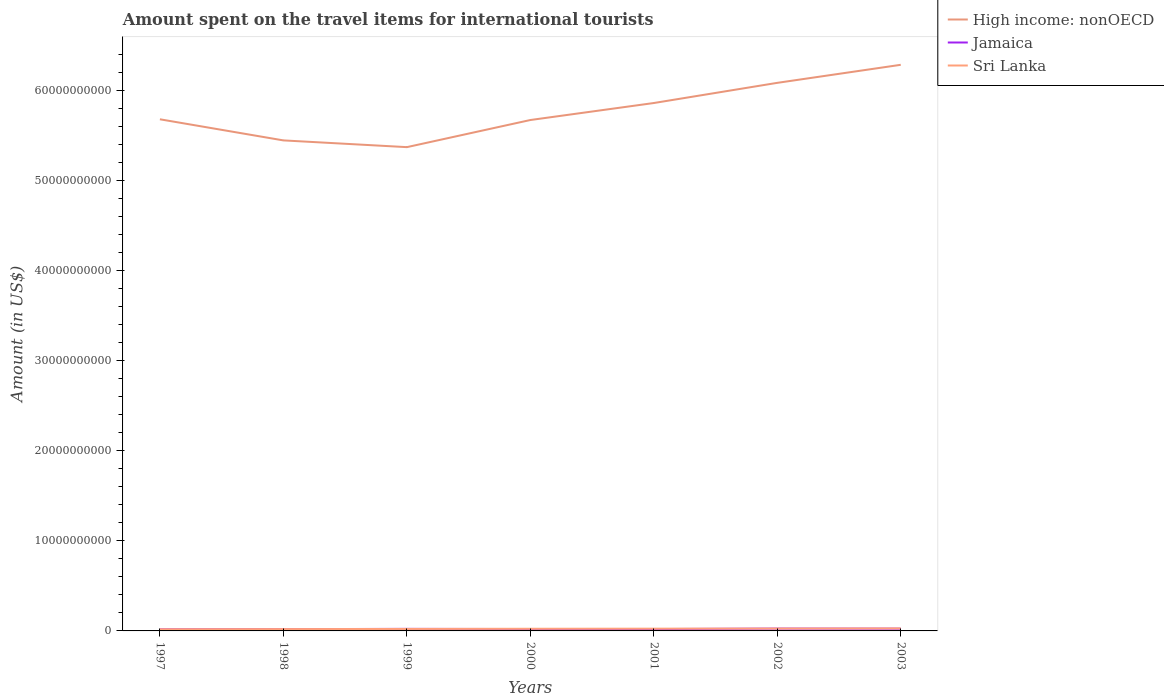Does the line corresponding to Sri Lanka intersect with the line corresponding to High income: nonOECD?
Provide a short and direct response. No. Is the number of lines equal to the number of legend labels?
Keep it short and to the point. Yes. Across all years, what is the maximum amount spent on the travel items for international tourists in High income: nonOECD?
Your answer should be very brief. 5.37e+1. What is the total amount spent on the travel items for international tourists in Jamaica in the graph?
Provide a succinct answer. -5.20e+07. What is the difference between the highest and the second highest amount spent on the travel items for international tourists in High income: nonOECD?
Provide a succinct answer. 9.14e+09. What is the difference between the highest and the lowest amount spent on the travel items for international tourists in Sri Lanka?
Provide a short and direct response. 4. Is the amount spent on the travel items for international tourists in Jamaica strictly greater than the amount spent on the travel items for international tourists in Sri Lanka over the years?
Ensure brevity in your answer.  No. What is the difference between two consecutive major ticks on the Y-axis?
Ensure brevity in your answer.  1.00e+1. Are the values on the major ticks of Y-axis written in scientific E-notation?
Keep it short and to the point. No. Does the graph contain any zero values?
Your response must be concise. No. Does the graph contain grids?
Make the answer very short. No. Where does the legend appear in the graph?
Make the answer very short. Top right. How many legend labels are there?
Keep it short and to the point. 3. How are the legend labels stacked?
Your answer should be compact. Vertical. What is the title of the graph?
Your answer should be very brief. Amount spent on the travel items for international tourists. What is the label or title of the X-axis?
Provide a succinct answer. Years. What is the label or title of the Y-axis?
Provide a succinct answer. Amount (in US$). What is the Amount (in US$) of High income: nonOECD in 1997?
Your answer should be very brief. 5.68e+1. What is the Amount (in US$) in Jamaica in 1997?
Make the answer very short. 1.81e+08. What is the Amount (in US$) of Sri Lanka in 1997?
Offer a terse response. 1.80e+08. What is the Amount (in US$) in High income: nonOECD in 1998?
Keep it short and to the point. 5.44e+1. What is the Amount (in US$) in Jamaica in 1998?
Provide a short and direct response. 1.98e+08. What is the Amount (in US$) of Sri Lanka in 1998?
Provide a short and direct response. 2.02e+08. What is the Amount (in US$) in High income: nonOECD in 1999?
Provide a succinct answer. 5.37e+1. What is the Amount (in US$) in Jamaica in 1999?
Offer a very short reply. 2.27e+08. What is the Amount (in US$) in Sri Lanka in 1999?
Make the answer very short. 2.18e+08. What is the Amount (in US$) in High income: nonOECD in 2000?
Your response must be concise. 5.67e+1. What is the Amount (in US$) in Jamaica in 2000?
Your response must be concise. 2.09e+08. What is the Amount (in US$) of Sri Lanka in 2000?
Your response must be concise. 2.40e+08. What is the Amount (in US$) of High income: nonOECD in 2001?
Offer a very short reply. 5.86e+1. What is the Amount (in US$) of Jamaica in 2001?
Your response must be concise. 2.06e+08. What is the Amount (in US$) of Sri Lanka in 2001?
Your answer should be very brief. 2.50e+08. What is the Amount (in US$) in High income: nonOECD in 2002?
Your response must be concise. 6.08e+1. What is the Amount (in US$) in Jamaica in 2002?
Your response must be concise. 2.58e+08. What is the Amount (in US$) of Sri Lanka in 2002?
Your answer should be very brief. 2.63e+08. What is the Amount (in US$) in High income: nonOECD in 2003?
Offer a terse response. 6.28e+1. What is the Amount (in US$) of Jamaica in 2003?
Your answer should be compact. 2.52e+08. What is the Amount (in US$) in Sri Lanka in 2003?
Your answer should be compact. 2.79e+08. Across all years, what is the maximum Amount (in US$) of High income: nonOECD?
Give a very brief answer. 6.28e+1. Across all years, what is the maximum Amount (in US$) of Jamaica?
Offer a terse response. 2.58e+08. Across all years, what is the maximum Amount (in US$) of Sri Lanka?
Provide a succinct answer. 2.79e+08. Across all years, what is the minimum Amount (in US$) in High income: nonOECD?
Keep it short and to the point. 5.37e+1. Across all years, what is the minimum Amount (in US$) in Jamaica?
Make the answer very short. 1.81e+08. Across all years, what is the minimum Amount (in US$) in Sri Lanka?
Make the answer very short. 1.80e+08. What is the total Amount (in US$) of High income: nonOECD in the graph?
Make the answer very short. 4.04e+11. What is the total Amount (in US$) of Jamaica in the graph?
Keep it short and to the point. 1.53e+09. What is the total Amount (in US$) of Sri Lanka in the graph?
Offer a very short reply. 1.63e+09. What is the difference between the Amount (in US$) in High income: nonOECD in 1997 and that in 1998?
Provide a succinct answer. 2.34e+09. What is the difference between the Amount (in US$) in Jamaica in 1997 and that in 1998?
Offer a terse response. -1.70e+07. What is the difference between the Amount (in US$) in Sri Lanka in 1997 and that in 1998?
Your answer should be compact. -2.20e+07. What is the difference between the Amount (in US$) of High income: nonOECD in 1997 and that in 1999?
Provide a succinct answer. 3.09e+09. What is the difference between the Amount (in US$) in Jamaica in 1997 and that in 1999?
Give a very brief answer. -4.60e+07. What is the difference between the Amount (in US$) in Sri Lanka in 1997 and that in 1999?
Make the answer very short. -3.80e+07. What is the difference between the Amount (in US$) in High income: nonOECD in 1997 and that in 2000?
Your response must be concise. 8.31e+07. What is the difference between the Amount (in US$) in Jamaica in 1997 and that in 2000?
Make the answer very short. -2.80e+07. What is the difference between the Amount (in US$) of Sri Lanka in 1997 and that in 2000?
Provide a short and direct response. -6.00e+07. What is the difference between the Amount (in US$) of High income: nonOECD in 1997 and that in 2001?
Ensure brevity in your answer.  -1.80e+09. What is the difference between the Amount (in US$) in Jamaica in 1997 and that in 2001?
Give a very brief answer. -2.50e+07. What is the difference between the Amount (in US$) in Sri Lanka in 1997 and that in 2001?
Your response must be concise. -7.00e+07. What is the difference between the Amount (in US$) of High income: nonOECD in 1997 and that in 2002?
Your answer should be very brief. -4.04e+09. What is the difference between the Amount (in US$) of Jamaica in 1997 and that in 2002?
Your answer should be compact. -7.70e+07. What is the difference between the Amount (in US$) in Sri Lanka in 1997 and that in 2002?
Provide a succinct answer. -8.30e+07. What is the difference between the Amount (in US$) of High income: nonOECD in 1997 and that in 2003?
Provide a succinct answer. -6.05e+09. What is the difference between the Amount (in US$) of Jamaica in 1997 and that in 2003?
Keep it short and to the point. -7.10e+07. What is the difference between the Amount (in US$) of Sri Lanka in 1997 and that in 2003?
Your answer should be very brief. -9.90e+07. What is the difference between the Amount (in US$) in High income: nonOECD in 1998 and that in 1999?
Your answer should be compact. 7.48e+08. What is the difference between the Amount (in US$) in Jamaica in 1998 and that in 1999?
Your response must be concise. -2.90e+07. What is the difference between the Amount (in US$) in Sri Lanka in 1998 and that in 1999?
Your answer should be compact. -1.60e+07. What is the difference between the Amount (in US$) in High income: nonOECD in 1998 and that in 2000?
Offer a terse response. -2.26e+09. What is the difference between the Amount (in US$) in Jamaica in 1998 and that in 2000?
Keep it short and to the point. -1.10e+07. What is the difference between the Amount (in US$) of Sri Lanka in 1998 and that in 2000?
Provide a succinct answer. -3.80e+07. What is the difference between the Amount (in US$) in High income: nonOECD in 1998 and that in 2001?
Offer a terse response. -4.15e+09. What is the difference between the Amount (in US$) of Jamaica in 1998 and that in 2001?
Your response must be concise. -8.00e+06. What is the difference between the Amount (in US$) in Sri Lanka in 1998 and that in 2001?
Offer a terse response. -4.80e+07. What is the difference between the Amount (in US$) in High income: nonOECD in 1998 and that in 2002?
Provide a short and direct response. -6.39e+09. What is the difference between the Amount (in US$) in Jamaica in 1998 and that in 2002?
Make the answer very short. -6.00e+07. What is the difference between the Amount (in US$) of Sri Lanka in 1998 and that in 2002?
Provide a short and direct response. -6.10e+07. What is the difference between the Amount (in US$) of High income: nonOECD in 1998 and that in 2003?
Offer a very short reply. -8.39e+09. What is the difference between the Amount (in US$) in Jamaica in 1998 and that in 2003?
Keep it short and to the point. -5.40e+07. What is the difference between the Amount (in US$) in Sri Lanka in 1998 and that in 2003?
Provide a short and direct response. -7.70e+07. What is the difference between the Amount (in US$) of High income: nonOECD in 1999 and that in 2000?
Your answer should be compact. -3.01e+09. What is the difference between the Amount (in US$) in Jamaica in 1999 and that in 2000?
Your answer should be compact. 1.80e+07. What is the difference between the Amount (in US$) in Sri Lanka in 1999 and that in 2000?
Ensure brevity in your answer.  -2.20e+07. What is the difference between the Amount (in US$) of High income: nonOECD in 1999 and that in 2001?
Offer a terse response. -4.90e+09. What is the difference between the Amount (in US$) of Jamaica in 1999 and that in 2001?
Provide a short and direct response. 2.10e+07. What is the difference between the Amount (in US$) in Sri Lanka in 1999 and that in 2001?
Ensure brevity in your answer.  -3.20e+07. What is the difference between the Amount (in US$) of High income: nonOECD in 1999 and that in 2002?
Give a very brief answer. -7.14e+09. What is the difference between the Amount (in US$) of Jamaica in 1999 and that in 2002?
Make the answer very short. -3.10e+07. What is the difference between the Amount (in US$) in Sri Lanka in 1999 and that in 2002?
Make the answer very short. -4.50e+07. What is the difference between the Amount (in US$) of High income: nonOECD in 1999 and that in 2003?
Your response must be concise. -9.14e+09. What is the difference between the Amount (in US$) in Jamaica in 1999 and that in 2003?
Make the answer very short. -2.50e+07. What is the difference between the Amount (in US$) of Sri Lanka in 1999 and that in 2003?
Ensure brevity in your answer.  -6.10e+07. What is the difference between the Amount (in US$) in High income: nonOECD in 2000 and that in 2001?
Make the answer very short. -1.89e+09. What is the difference between the Amount (in US$) in Jamaica in 2000 and that in 2001?
Provide a succinct answer. 3.00e+06. What is the difference between the Amount (in US$) in Sri Lanka in 2000 and that in 2001?
Give a very brief answer. -1.00e+07. What is the difference between the Amount (in US$) in High income: nonOECD in 2000 and that in 2002?
Your answer should be very brief. -4.13e+09. What is the difference between the Amount (in US$) in Jamaica in 2000 and that in 2002?
Offer a terse response. -4.90e+07. What is the difference between the Amount (in US$) of Sri Lanka in 2000 and that in 2002?
Give a very brief answer. -2.30e+07. What is the difference between the Amount (in US$) of High income: nonOECD in 2000 and that in 2003?
Provide a short and direct response. -6.13e+09. What is the difference between the Amount (in US$) of Jamaica in 2000 and that in 2003?
Keep it short and to the point. -4.30e+07. What is the difference between the Amount (in US$) of Sri Lanka in 2000 and that in 2003?
Offer a terse response. -3.90e+07. What is the difference between the Amount (in US$) in High income: nonOECD in 2001 and that in 2002?
Offer a very short reply. -2.24e+09. What is the difference between the Amount (in US$) in Jamaica in 2001 and that in 2002?
Keep it short and to the point. -5.20e+07. What is the difference between the Amount (in US$) in Sri Lanka in 2001 and that in 2002?
Make the answer very short. -1.30e+07. What is the difference between the Amount (in US$) of High income: nonOECD in 2001 and that in 2003?
Offer a terse response. -4.24e+09. What is the difference between the Amount (in US$) of Jamaica in 2001 and that in 2003?
Your answer should be very brief. -4.60e+07. What is the difference between the Amount (in US$) of Sri Lanka in 2001 and that in 2003?
Provide a short and direct response. -2.90e+07. What is the difference between the Amount (in US$) of High income: nonOECD in 2002 and that in 2003?
Your response must be concise. -2.00e+09. What is the difference between the Amount (in US$) in Sri Lanka in 2002 and that in 2003?
Offer a terse response. -1.60e+07. What is the difference between the Amount (in US$) in High income: nonOECD in 1997 and the Amount (in US$) in Jamaica in 1998?
Offer a very short reply. 5.66e+1. What is the difference between the Amount (in US$) of High income: nonOECD in 1997 and the Amount (in US$) of Sri Lanka in 1998?
Give a very brief answer. 5.66e+1. What is the difference between the Amount (in US$) in Jamaica in 1997 and the Amount (in US$) in Sri Lanka in 1998?
Ensure brevity in your answer.  -2.10e+07. What is the difference between the Amount (in US$) in High income: nonOECD in 1997 and the Amount (in US$) in Jamaica in 1999?
Your answer should be compact. 5.66e+1. What is the difference between the Amount (in US$) of High income: nonOECD in 1997 and the Amount (in US$) of Sri Lanka in 1999?
Provide a succinct answer. 5.66e+1. What is the difference between the Amount (in US$) in Jamaica in 1997 and the Amount (in US$) in Sri Lanka in 1999?
Ensure brevity in your answer.  -3.70e+07. What is the difference between the Amount (in US$) of High income: nonOECD in 1997 and the Amount (in US$) of Jamaica in 2000?
Make the answer very short. 5.66e+1. What is the difference between the Amount (in US$) in High income: nonOECD in 1997 and the Amount (in US$) in Sri Lanka in 2000?
Give a very brief answer. 5.65e+1. What is the difference between the Amount (in US$) of Jamaica in 1997 and the Amount (in US$) of Sri Lanka in 2000?
Provide a short and direct response. -5.90e+07. What is the difference between the Amount (in US$) in High income: nonOECD in 1997 and the Amount (in US$) in Jamaica in 2001?
Keep it short and to the point. 5.66e+1. What is the difference between the Amount (in US$) of High income: nonOECD in 1997 and the Amount (in US$) of Sri Lanka in 2001?
Your answer should be compact. 5.65e+1. What is the difference between the Amount (in US$) of Jamaica in 1997 and the Amount (in US$) of Sri Lanka in 2001?
Your answer should be very brief. -6.90e+07. What is the difference between the Amount (in US$) of High income: nonOECD in 1997 and the Amount (in US$) of Jamaica in 2002?
Provide a short and direct response. 5.65e+1. What is the difference between the Amount (in US$) of High income: nonOECD in 1997 and the Amount (in US$) of Sri Lanka in 2002?
Your response must be concise. 5.65e+1. What is the difference between the Amount (in US$) of Jamaica in 1997 and the Amount (in US$) of Sri Lanka in 2002?
Provide a short and direct response. -8.20e+07. What is the difference between the Amount (in US$) in High income: nonOECD in 1997 and the Amount (in US$) in Jamaica in 2003?
Give a very brief answer. 5.65e+1. What is the difference between the Amount (in US$) in High income: nonOECD in 1997 and the Amount (in US$) in Sri Lanka in 2003?
Keep it short and to the point. 5.65e+1. What is the difference between the Amount (in US$) of Jamaica in 1997 and the Amount (in US$) of Sri Lanka in 2003?
Give a very brief answer. -9.80e+07. What is the difference between the Amount (in US$) in High income: nonOECD in 1998 and the Amount (in US$) in Jamaica in 1999?
Provide a short and direct response. 5.42e+1. What is the difference between the Amount (in US$) of High income: nonOECD in 1998 and the Amount (in US$) of Sri Lanka in 1999?
Keep it short and to the point. 5.42e+1. What is the difference between the Amount (in US$) of Jamaica in 1998 and the Amount (in US$) of Sri Lanka in 1999?
Provide a succinct answer. -2.00e+07. What is the difference between the Amount (in US$) in High income: nonOECD in 1998 and the Amount (in US$) in Jamaica in 2000?
Your response must be concise. 5.42e+1. What is the difference between the Amount (in US$) of High income: nonOECD in 1998 and the Amount (in US$) of Sri Lanka in 2000?
Your response must be concise. 5.42e+1. What is the difference between the Amount (in US$) in Jamaica in 1998 and the Amount (in US$) in Sri Lanka in 2000?
Provide a short and direct response. -4.20e+07. What is the difference between the Amount (in US$) in High income: nonOECD in 1998 and the Amount (in US$) in Jamaica in 2001?
Make the answer very short. 5.42e+1. What is the difference between the Amount (in US$) in High income: nonOECD in 1998 and the Amount (in US$) in Sri Lanka in 2001?
Your answer should be compact. 5.42e+1. What is the difference between the Amount (in US$) of Jamaica in 1998 and the Amount (in US$) of Sri Lanka in 2001?
Keep it short and to the point. -5.20e+07. What is the difference between the Amount (in US$) of High income: nonOECD in 1998 and the Amount (in US$) of Jamaica in 2002?
Your answer should be very brief. 5.42e+1. What is the difference between the Amount (in US$) in High income: nonOECD in 1998 and the Amount (in US$) in Sri Lanka in 2002?
Your response must be concise. 5.42e+1. What is the difference between the Amount (in US$) in Jamaica in 1998 and the Amount (in US$) in Sri Lanka in 2002?
Make the answer very short. -6.50e+07. What is the difference between the Amount (in US$) of High income: nonOECD in 1998 and the Amount (in US$) of Jamaica in 2003?
Give a very brief answer. 5.42e+1. What is the difference between the Amount (in US$) in High income: nonOECD in 1998 and the Amount (in US$) in Sri Lanka in 2003?
Give a very brief answer. 5.42e+1. What is the difference between the Amount (in US$) in Jamaica in 1998 and the Amount (in US$) in Sri Lanka in 2003?
Your response must be concise. -8.10e+07. What is the difference between the Amount (in US$) of High income: nonOECD in 1999 and the Amount (in US$) of Jamaica in 2000?
Keep it short and to the point. 5.35e+1. What is the difference between the Amount (in US$) in High income: nonOECD in 1999 and the Amount (in US$) in Sri Lanka in 2000?
Offer a very short reply. 5.35e+1. What is the difference between the Amount (in US$) in Jamaica in 1999 and the Amount (in US$) in Sri Lanka in 2000?
Provide a short and direct response. -1.30e+07. What is the difference between the Amount (in US$) of High income: nonOECD in 1999 and the Amount (in US$) of Jamaica in 2001?
Give a very brief answer. 5.35e+1. What is the difference between the Amount (in US$) in High income: nonOECD in 1999 and the Amount (in US$) in Sri Lanka in 2001?
Ensure brevity in your answer.  5.34e+1. What is the difference between the Amount (in US$) of Jamaica in 1999 and the Amount (in US$) of Sri Lanka in 2001?
Your response must be concise. -2.30e+07. What is the difference between the Amount (in US$) of High income: nonOECD in 1999 and the Amount (in US$) of Jamaica in 2002?
Your answer should be compact. 5.34e+1. What is the difference between the Amount (in US$) in High income: nonOECD in 1999 and the Amount (in US$) in Sri Lanka in 2002?
Make the answer very short. 5.34e+1. What is the difference between the Amount (in US$) of Jamaica in 1999 and the Amount (in US$) of Sri Lanka in 2002?
Your answer should be compact. -3.60e+07. What is the difference between the Amount (in US$) of High income: nonOECD in 1999 and the Amount (in US$) of Jamaica in 2003?
Your response must be concise. 5.34e+1. What is the difference between the Amount (in US$) of High income: nonOECD in 1999 and the Amount (in US$) of Sri Lanka in 2003?
Your answer should be very brief. 5.34e+1. What is the difference between the Amount (in US$) of Jamaica in 1999 and the Amount (in US$) of Sri Lanka in 2003?
Your answer should be compact. -5.20e+07. What is the difference between the Amount (in US$) in High income: nonOECD in 2000 and the Amount (in US$) in Jamaica in 2001?
Ensure brevity in your answer.  5.65e+1. What is the difference between the Amount (in US$) in High income: nonOECD in 2000 and the Amount (in US$) in Sri Lanka in 2001?
Keep it short and to the point. 5.64e+1. What is the difference between the Amount (in US$) of Jamaica in 2000 and the Amount (in US$) of Sri Lanka in 2001?
Offer a terse response. -4.10e+07. What is the difference between the Amount (in US$) in High income: nonOECD in 2000 and the Amount (in US$) in Jamaica in 2002?
Provide a short and direct response. 5.64e+1. What is the difference between the Amount (in US$) in High income: nonOECD in 2000 and the Amount (in US$) in Sri Lanka in 2002?
Your answer should be compact. 5.64e+1. What is the difference between the Amount (in US$) in Jamaica in 2000 and the Amount (in US$) in Sri Lanka in 2002?
Make the answer very short. -5.40e+07. What is the difference between the Amount (in US$) of High income: nonOECD in 2000 and the Amount (in US$) of Jamaica in 2003?
Your answer should be very brief. 5.64e+1. What is the difference between the Amount (in US$) of High income: nonOECD in 2000 and the Amount (in US$) of Sri Lanka in 2003?
Your response must be concise. 5.64e+1. What is the difference between the Amount (in US$) in Jamaica in 2000 and the Amount (in US$) in Sri Lanka in 2003?
Ensure brevity in your answer.  -7.00e+07. What is the difference between the Amount (in US$) in High income: nonOECD in 2001 and the Amount (in US$) in Jamaica in 2002?
Offer a very short reply. 5.83e+1. What is the difference between the Amount (in US$) of High income: nonOECD in 2001 and the Amount (in US$) of Sri Lanka in 2002?
Give a very brief answer. 5.83e+1. What is the difference between the Amount (in US$) in Jamaica in 2001 and the Amount (in US$) in Sri Lanka in 2002?
Provide a succinct answer. -5.70e+07. What is the difference between the Amount (in US$) of High income: nonOECD in 2001 and the Amount (in US$) of Jamaica in 2003?
Offer a terse response. 5.83e+1. What is the difference between the Amount (in US$) of High income: nonOECD in 2001 and the Amount (in US$) of Sri Lanka in 2003?
Keep it short and to the point. 5.83e+1. What is the difference between the Amount (in US$) of Jamaica in 2001 and the Amount (in US$) of Sri Lanka in 2003?
Provide a succinct answer. -7.30e+07. What is the difference between the Amount (in US$) of High income: nonOECD in 2002 and the Amount (in US$) of Jamaica in 2003?
Offer a very short reply. 6.06e+1. What is the difference between the Amount (in US$) of High income: nonOECD in 2002 and the Amount (in US$) of Sri Lanka in 2003?
Ensure brevity in your answer.  6.05e+1. What is the difference between the Amount (in US$) of Jamaica in 2002 and the Amount (in US$) of Sri Lanka in 2003?
Your answer should be compact. -2.10e+07. What is the average Amount (in US$) of High income: nonOECD per year?
Provide a short and direct response. 5.77e+1. What is the average Amount (in US$) of Jamaica per year?
Make the answer very short. 2.19e+08. What is the average Amount (in US$) in Sri Lanka per year?
Your answer should be compact. 2.33e+08. In the year 1997, what is the difference between the Amount (in US$) in High income: nonOECD and Amount (in US$) in Jamaica?
Give a very brief answer. 5.66e+1. In the year 1997, what is the difference between the Amount (in US$) in High income: nonOECD and Amount (in US$) in Sri Lanka?
Provide a succinct answer. 5.66e+1. In the year 1997, what is the difference between the Amount (in US$) of Jamaica and Amount (in US$) of Sri Lanka?
Your response must be concise. 1.00e+06. In the year 1998, what is the difference between the Amount (in US$) in High income: nonOECD and Amount (in US$) in Jamaica?
Keep it short and to the point. 5.42e+1. In the year 1998, what is the difference between the Amount (in US$) in High income: nonOECD and Amount (in US$) in Sri Lanka?
Your response must be concise. 5.42e+1. In the year 1998, what is the difference between the Amount (in US$) of Jamaica and Amount (in US$) of Sri Lanka?
Your answer should be compact. -4.00e+06. In the year 1999, what is the difference between the Amount (in US$) of High income: nonOECD and Amount (in US$) of Jamaica?
Your answer should be compact. 5.35e+1. In the year 1999, what is the difference between the Amount (in US$) in High income: nonOECD and Amount (in US$) in Sri Lanka?
Offer a terse response. 5.35e+1. In the year 1999, what is the difference between the Amount (in US$) in Jamaica and Amount (in US$) in Sri Lanka?
Offer a very short reply. 9.00e+06. In the year 2000, what is the difference between the Amount (in US$) in High income: nonOECD and Amount (in US$) in Jamaica?
Keep it short and to the point. 5.65e+1. In the year 2000, what is the difference between the Amount (in US$) of High income: nonOECD and Amount (in US$) of Sri Lanka?
Your answer should be very brief. 5.65e+1. In the year 2000, what is the difference between the Amount (in US$) of Jamaica and Amount (in US$) of Sri Lanka?
Your answer should be very brief. -3.10e+07. In the year 2001, what is the difference between the Amount (in US$) of High income: nonOECD and Amount (in US$) of Jamaica?
Your answer should be compact. 5.84e+1. In the year 2001, what is the difference between the Amount (in US$) in High income: nonOECD and Amount (in US$) in Sri Lanka?
Ensure brevity in your answer.  5.83e+1. In the year 2001, what is the difference between the Amount (in US$) of Jamaica and Amount (in US$) of Sri Lanka?
Offer a very short reply. -4.40e+07. In the year 2002, what is the difference between the Amount (in US$) of High income: nonOECD and Amount (in US$) of Jamaica?
Provide a succinct answer. 6.06e+1. In the year 2002, what is the difference between the Amount (in US$) in High income: nonOECD and Amount (in US$) in Sri Lanka?
Your answer should be compact. 6.06e+1. In the year 2002, what is the difference between the Amount (in US$) in Jamaica and Amount (in US$) in Sri Lanka?
Provide a short and direct response. -5.00e+06. In the year 2003, what is the difference between the Amount (in US$) of High income: nonOECD and Amount (in US$) of Jamaica?
Ensure brevity in your answer.  6.26e+1. In the year 2003, what is the difference between the Amount (in US$) of High income: nonOECD and Amount (in US$) of Sri Lanka?
Your response must be concise. 6.25e+1. In the year 2003, what is the difference between the Amount (in US$) of Jamaica and Amount (in US$) of Sri Lanka?
Your answer should be compact. -2.70e+07. What is the ratio of the Amount (in US$) of High income: nonOECD in 1997 to that in 1998?
Provide a succinct answer. 1.04. What is the ratio of the Amount (in US$) in Jamaica in 1997 to that in 1998?
Your response must be concise. 0.91. What is the ratio of the Amount (in US$) of Sri Lanka in 1997 to that in 1998?
Your response must be concise. 0.89. What is the ratio of the Amount (in US$) of High income: nonOECD in 1997 to that in 1999?
Keep it short and to the point. 1.06. What is the ratio of the Amount (in US$) of Jamaica in 1997 to that in 1999?
Your response must be concise. 0.8. What is the ratio of the Amount (in US$) of Sri Lanka in 1997 to that in 1999?
Provide a succinct answer. 0.83. What is the ratio of the Amount (in US$) in Jamaica in 1997 to that in 2000?
Make the answer very short. 0.87. What is the ratio of the Amount (in US$) in High income: nonOECD in 1997 to that in 2001?
Your answer should be compact. 0.97. What is the ratio of the Amount (in US$) in Jamaica in 1997 to that in 2001?
Offer a very short reply. 0.88. What is the ratio of the Amount (in US$) in Sri Lanka in 1997 to that in 2001?
Make the answer very short. 0.72. What is the ratio of the Amount (in US$) in High income: nonOECD in 1997 to that in 2002?
Ensure brevity in your answer.  0.93. What is the ratio of the Amount (in US$) of Jamaica in 1997 to that in 2002?
Make the answer very short. 0.7. What is the ratio of the Amount (in US$) of Sri Lanka in 1997 to that in 2002?
Your answer should be very brief. 0.68. What is the ratio of the Amount (in US$) of High income: nonOECD in 1997 to that in 2003?
Your response must be concise. 0.9. What is the ratio of the Amount (in US$) in Jamaica in 1997 to that in 2003?
Provide a short and direct response. 0.72. What is the ratio of the Amount (in US$) of Sri Lanka in 1997 to that in 2003?
Keep it short and to the point. 0.65. What is the ratio of the Amount (in US$) of High income: nonOECD in 1998 to that in 1999?
Your answer should be very brief. 1.01. What is the ratio of the Amount (in US$) in Jamaica in 1998 to that in 1999?
Offer a very short reply. 0.87. What is the ratio of the Amount (in US$) of Sri Lanka in 1998 to that in 1999?
Provide a succinct answer. 0.93. What is the ratio of the Amount (in US$) in High income: nonOECD in 1998 to that in 2000?
Offer a terse response. 0.96. What is the ratio of the Amount (in US$) of Sri Lanka in 1998 to that in 2000?
Provide a succinct answer. 0.84. What is the ratio of the Amount (in US$) of High income: nonOECD in 1998 to that in 2001?
Offer a very short reply. 0.93. What is the ratio of the Amount (in US$) of Jamaica in 1998 to that in 2001?
Your answer should be very brief. 0.96. What is the ratio of the Amount (in US$) of Sri Lanka in 1998 to that in 2001?
Make the answer very short. 0.81. What is the ratio of the Amount (in US$) of High income: nonOECD in 1998 to that in 2002?
Your response must be concise. 0.9. What is the ratio of the Amount (in US$) of Jamaica in 1998 to that in 2002?
Give a very brief answer. 0.77. What is the ratio of the Amount (in US$) in Sri Lanka in 1998 to that in 2002?
Provide a succinct answer. 0.77. What is the ratio of the Amount (in US$) of High income: nonOECD in 1998 to that in 2003?
Offer a terse response. 0.87. What is the ratio of the Amount (in US$) of Jamaica in 1998 to that in 2003?
Ensure brevity in your answer.  0.79. What is the ratio of the Amount (in US$) of Sri Lanka in 1998 to that in 2003?
Make the answer very short. 0.72. What is the ratio of the Amount (in US$) in High income: nonOECD in 1999 to that in 2000?
Provide a short and direct response. 0.95. What is the ratio of the Amount (in US$) in Jamaica in 1999 to that in 2000?
Your answer should be compact. 1.09. What is the ratio of the Amount (in US$) of Sri Lanka in 1999 to that in 2000?
Ensure brevity in your answer.  0.91. What is the ratio of the Amount (in US$) of High income: nonOECD in 1999 to that in 2001?
Keep it short and to the point. 0.92. What is the ratio of the Amount (in US$) in Jamaica in 1999 to that in 2001?
Give a very brief answer. 1.1. What is the ratio of the Amount (in US$) in Sri Lanka in 1999 to that in 2001?
Your answer should be compact. 0.87. What is the ratio of the Amount (in US$) in High income: nonOECD in 1999 to that in 2002?
Provide a succinct answer. 0.88. What is the ratio of the Amount (in US$) of Jamaica in 1999 to that in 2002?
Make the answer very short. 0.88. What is the ratio of the Amount (in US$) in Sri Lanka in 1999 to that in 2002?
Offer a terse response. 0.83. What is the ratio of the Amount (in US$) of High income: nonOECD in 1999 to that in 2003?
Give a very brief answer. 0.85. What is the ratio of the Amount (in US$) of Jamaica in 1999 to that in 2003?
Offer a terse response. 0.9. What is the ratio of the Amount (in US$) of Sri Lanka in 1999 to that in 2003?
Make the answer very short. 0.78. What is the ratio of the Amount (in US$) in High income: nonOECD in 2000 to that in 2001?
Offer a terse response. 0.97. What is the ratio of the Amount (in US$) in Jamaica in 2000 to that in 2001?
Your answer should be compact. 1.01. What is the ratio of the Amount (in US$) in Sri Lanka in 2000 to that in 2001?
Give a very brief answer. 0.96. What is the ratio of the Amount (in US$) in High income: nonOECD in 2000 to that in 2002?
Your answer should be very brief. 0.93. What is the ratio of the Amount (in US$) in Jamaica in 2000 to that in 2002?
Provide a succinct answer. 0.81. What is the ratio of the Amount (in US$) of Sri Lanka in 2000 to that in 2002?
Keep it short and to the point. 0.91. What is the ratio of the Amount (in US$) in High income: nonOECD in 2000 to that in 2003?
Make the answer very short. 0.9. What is the ratio of the Amount (in US$) of Jamaica in 2000 to that in 2003?
Your answer should be very brief. 0.83. What is the ratio of the Amount (in US$) of Sri Lanka in 2000 to that in 2003?
Ensure brevity in your answer.  0.86. What is the ratio of the Amount (in US$) of High income: nonOECD in 2001 to that in 2002?
Give a very brief answer. 0.96. What is the ratio of the Amount (in US$) of Jamaica in 2001 to that in 2002?
Your answer should be compact. 0.8. What is the ratio of the Amount (in US$) in Sri Lanka in 2001 to that in 2002?
Make the answer very short. 0.95. What is the ratio of the Amount (in US$) in High income: nonOECD in 2001 to that in 2003?
Provide a succinct answer. 0.93. What is the ratio of the Amount (in US$) of Jamaica in 2001 to that in 2003?
Your answer should be very brief. 0.82. What is the ratio of the Amount (in US$) in Sri Lanka in 2001 to that in 2003?
Your answer should be compact. 0.9. What is the ratio of the Amount (in US$) in High income: nonOECD in 2002 to that in 2003?
Ensure brevity in your answer.  0.97. What is the ratio of the Amount (in US$) in Jamaica in 2002 to that in 2003?
Make the answer very short. 1.02. What is the ratio of the Amount (in US$) of Sri Lanka in 2002 to that in 2003?
Your answer should be very brief. 0.94. What is the difference between the highest and the second highest Amount (in US$) in High income: nonOECD?
Provide a succinct answer. 2.00e+09. What is the difference between the highest and the second highest Amount (in US$) of Sri Lanka?
Offer a terse response. 1.60e+07. What is the difference between the highest and the lowest Amount (in US$) of High income: nonOECD?
Provide a short and direct response. 9.14e+09. What is the difference between the highest and the lowest Amount (in US$) in Jamaica?
Ensure brevity in your answer.  7.70e+07. What is the difference between the highest and the lowest Amount (in US$) of Sri Lanka?
Ensure brevity in your answer.  9.90e+07. 